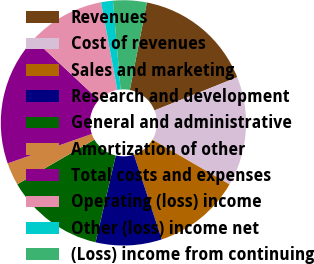<chart> <loc_0><loc_0><loc_500><loc_500><pie_chart><fcel>Revenues<fcel>Cost of revenues<fcel>Sales and marketing<fcel>Research and development<fcel>General and administrative<fcel>Amortization of other<fcel>Total costs and expenses<fcel>Operating (loss) income<fcel>Other (loss) income net<fcel>(Loss) income from continuing<nl><fcel>15.87%<fcel>14.44%<fcel>11.57%<fcel>8.71%<fcel>13.0%<fcel>2.99%<fcel>17.3%<fcel>10.14%<fcel>1.56%<fcel>4.42%<nl></chart> 